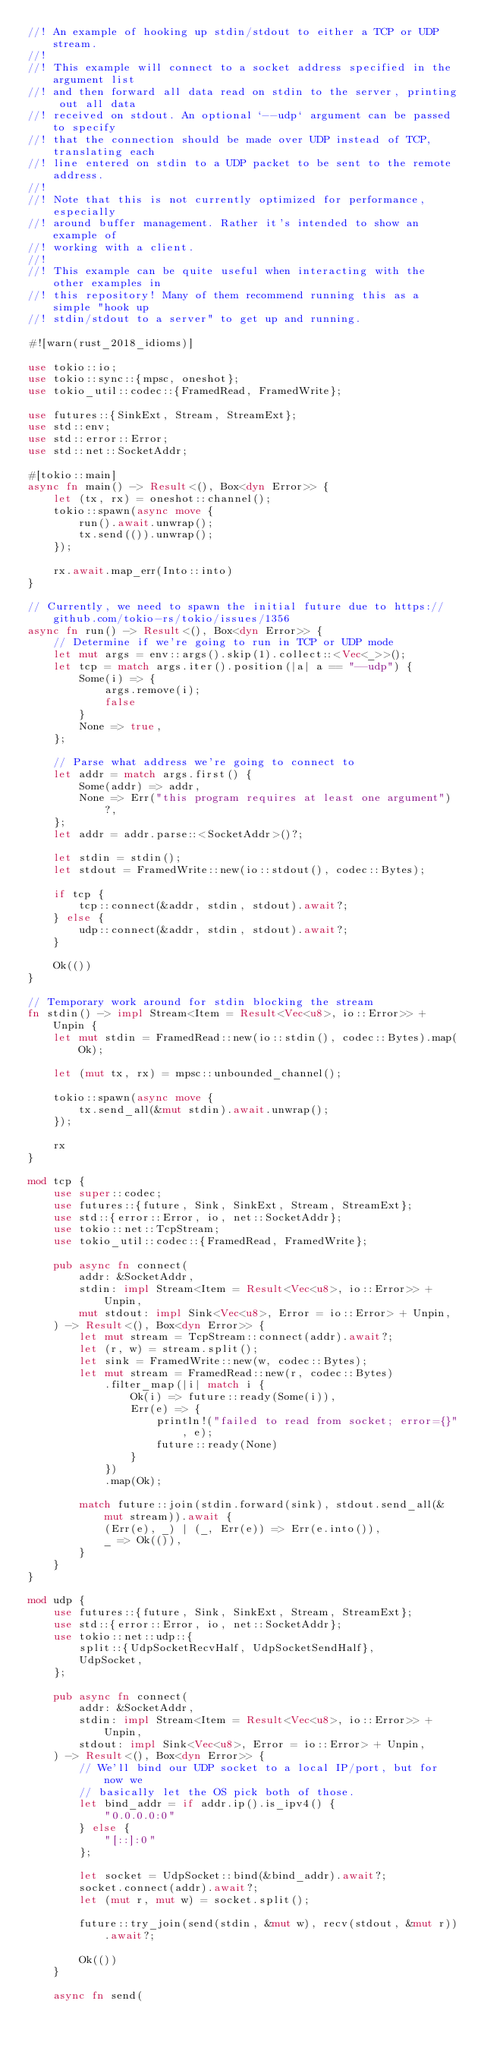Convert code to text. <code><loc_0><loc_0><loc_500><loc_500><_Rust_>//! An example of hooking up stdin/stdout to either a TCP or UDP stream.
//!
//! This example will connect to a socket address specified in the argument list
//! and then forward all data read on stdin to the server, printing out all data
//! received on stdout. An optional `--udp` argument can be passed to specify
//! that the connection should be made over UDP instead of TCP, translating each
//! line entered on stdin to a UDP packet to be sent to the remote address.
//!
//! Note that this is not currently optimized for performance, especially
//! around buffer management. Rather it's intended to show an example of
//! working with a client.
//!
//! This example can be quite useful when interacting with the other examples in
//! this repository! Many of them recommend running this as a simple "hook up
//! stdin/stdout to a server" to get up and running.

#![warn(rust_2018_idioms)]

use tokio::io;
use tokio::sync::{mpsc, oneshot};
use tokio_util::codec::{FramedRead, FramedWrite};

use futures::{SinkExt, Stream, StreamExt};
use std::env;
use std::error::Error;
use std::net::SocketAddr;

#[tokio::main]
async fn main() -> Result<(), Box<dyn Error>> {
    let (tx, rx) = oneshot::channel();
    tokio::spawn(async move {
        run().await.unwrap();
        tx.send(()).unwrap();
    });

    rx.await.map_err(Into::into)
}

// Currently, we need to spawn the initial future due to https://github.com/tokio-rs/tokio/issues/1356
async fn run() -> Result<(), Box<dyn Error>> {
    // Determine if we're going to run in TCP or UDP mode
    let mut args = env::args().skip(1).collect::<Vec<_>>();
    let tcp = match args.iter().position(|a| a == "--udp") {
        Some(i) => {
            args.remove(i);
            false
        }
        None => true,
    };

    // Parse what address we're going to connect to
    let addr = match args.first() {
        Some(addr) => addr,
        None => Err("this program requires at least one argument")?,
    };
    let addr = addr.parse::<SocketAddr>()?;

    let stdin = stdin();
    let stdout = FramedWrite::new(io::stdout(), codec::Bytes);

    if tcp {
        tcp::connect(&addr, stdin, stdout).await?;
    } else {
        udp::connect(&addr, stdin, stdout).await?;
    }

    Ok(())
}

// Temporary work around for stdin blocking the stream
fn stdin() -> impl Stream<Item = Result<Vec<u8>, io::Error>> + Unpin {
    let mut stdin = FramedRead::new(io::stdin(), codec::Bytes).map(Ok);

    let (mut tx, rx) = mpsc::unbounded_channel();

    tokio::spawn(async move {
        tx.send_all(&mut stdin).await.unwrap();
    });

    rx
}

mod tcp {
    use super::codec;
    use futures::{future, Sink, SinkExt, Stream, StreamExt};
    use std::{error::Error, io, net::SocketAddr};
    use tokio::net::TcpStream;
    use tokio_util::codec::{FramedRead, FramedWrite};

    pub async fn connect(
        addr: &SocketAddr,
        stdin: impl Stream<Item = Result<Vec<u8>, io::Error>> + Unpin,
        mut stdout: impl Sink<Vec<u8>, Error = io::Error> + Unpin,
    ) -> Result<(), Box<dyn Error>> {
        let mut stream = TcpStream::connect(addr).await?;
        let (r, w) = stream.split();
        let sink = FramedWrite::new(w, codec::Bytes);
        let mut stream = FramedRead::new(r, codec::Bytes)
            .filter_map(|i| match i {
                Ok(i) => future::ready(Some(i)),
                Err(e) => {
                    println!("failed to read from socket; error={}", e);
                    future::ready(None)
                }
            })
            .map(Ok);

        match future::join(stdin.forward(sink), stdout.send_all(&mut stream)).await {
            (Err(e), _) | (_, Err(e)) => Err(e.into()),
            _ => Ok(()),
        }
    }
}

mod udp {
    use futures::{future, Sink, SinkExt, Stream, StreamExt};
    use std::{error::Error, io, net::SocketAddr};
    use tokio::net::udp::{
        split::{UdpSocketRecvHalf, UdpSocketSendHalf},
        UdpSocket,
    };

    pub async fn connect(
        addr: &SocketAddr,
        stdin: impl Stream<Item = Result<Vec<u8>, io::Error>> + Unpin,
        stdout: impl Sink<Vec<u8>, Error = io::Error> + Unpin,
    ) -> Result<(), Box<dyn Error>> {
        // We'll bind our UDP socket to a local IP/port, but for now we
        // basically let the OS pick both of those.
        let bind_addr = if addr.ip().is_ipv4() {
            "0.0.0.0:0"
        } else {
            "[::]:0"
        };

        let socket = UdpSocket::bind(&bind_addr).await?;
        socket.connect(addr).await?;
        let (mut r, mut w) = socket.split();

        future::try_join(send(stdin, &mut w), recv(stdout, &mut r)).await?;

        Ok(())
    }

    async fn send(</code> 